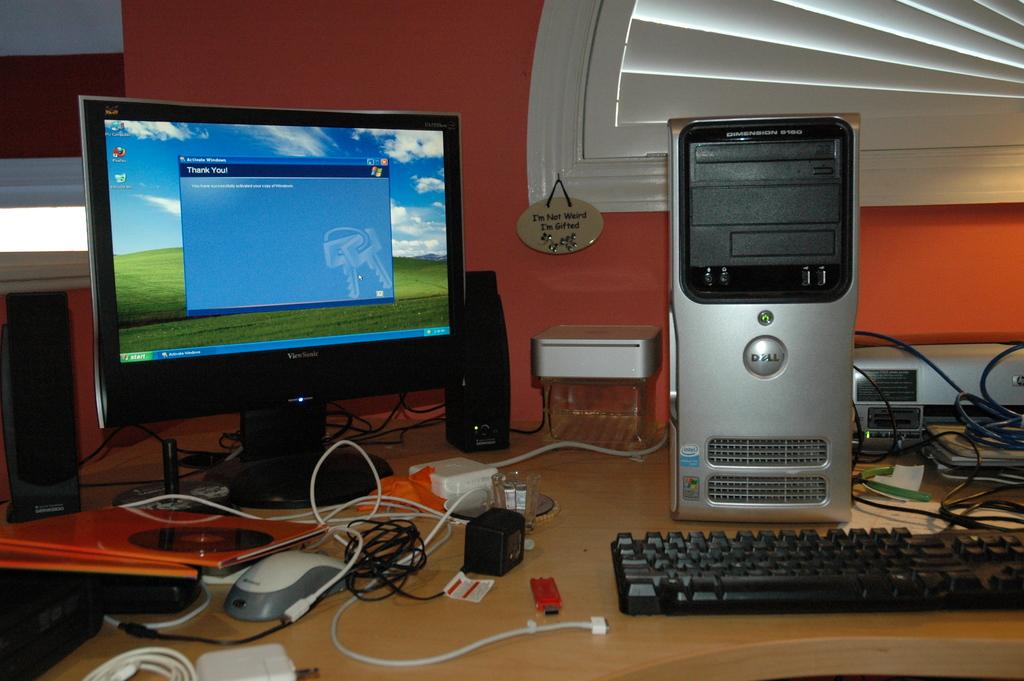What is written in the dark blue box on the screen? (2 words)?
Your answer should be very brief. Thank you. What company name is printed on the computer near the center?
Give a very brief answer. Dell. 